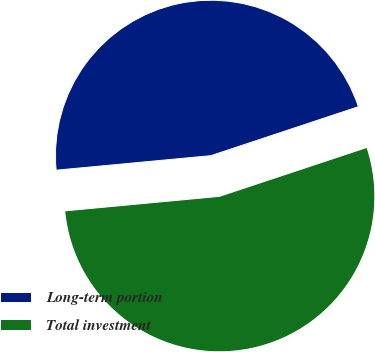Convert chart to OTSL. <chart><loc_0><loc_0><loc_500><loc_500><pie_chart><fcel>Long-term portion<fcel>Total investment<nl><fcel>46.39%<fcel>53.61%<nl></chart> 